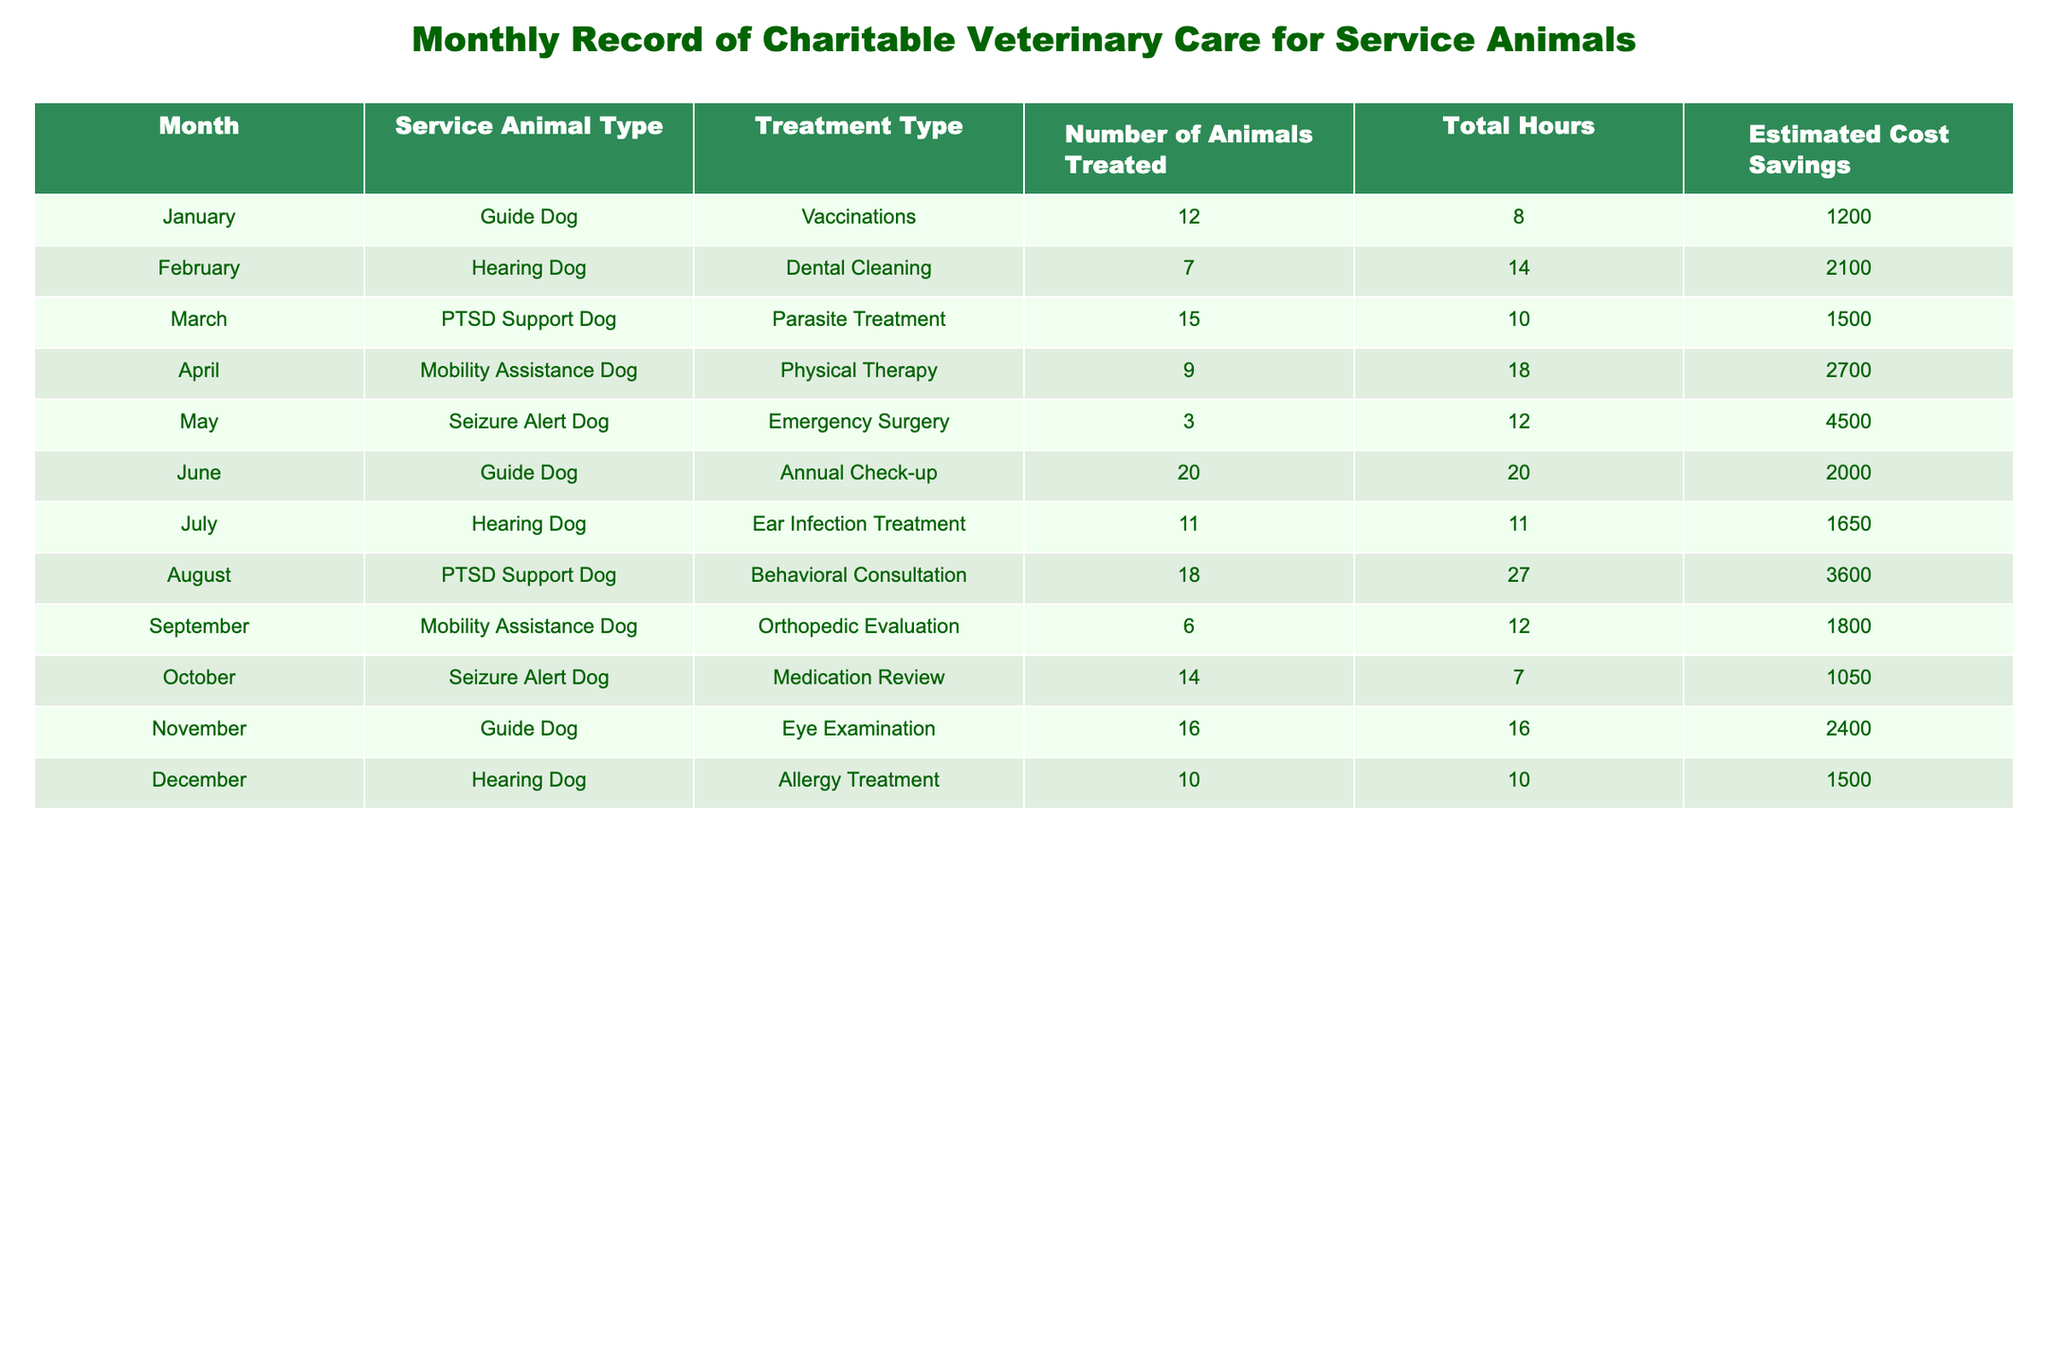What was the total number of animals treated in August? In August, 18 PTSD Support Dogs were treated according to the table.
Answer: 18 Which month had the highest estimated cost savings and how much was it? In May, the estimated cost savings for the treatment of 3 Seizure Alert Dogs for Emergency Surgery was $4500, which is the highest value in the table.
Answer: $4500 Which service animal type had the most treatments in a single month? In June, 20 Guide Dogs received their annual check-up, which is the highest single-month treatment count for any service animal type.
Answer: Guide Dog Did more animals receive dental cleaning or parasite treatment? In February, 7 animals received dental cleaning and in March, 15 animals received parasite treatment. Therefore, more animals received parasite treatment.
Answer: Yes What is the average estimated cost savings per treatment type for Guide Dogs over the year? The estimated cost savings for Guide Dogs in January ($1200), June ($2000), and November ($2400) total $5600. Dividing by the number of treatments (3) gives an average of $1866.67.
Answer: $1866.67 How many hours were spent on the treatment of Mobility Assistance Dogs in total? The total hours spent on Mobility Assistance Dogs were in April (18 hours) and September (12 hours), so 18 + 12 = 30 hours in total are spent on their treatment.
Answer: 30 hours 